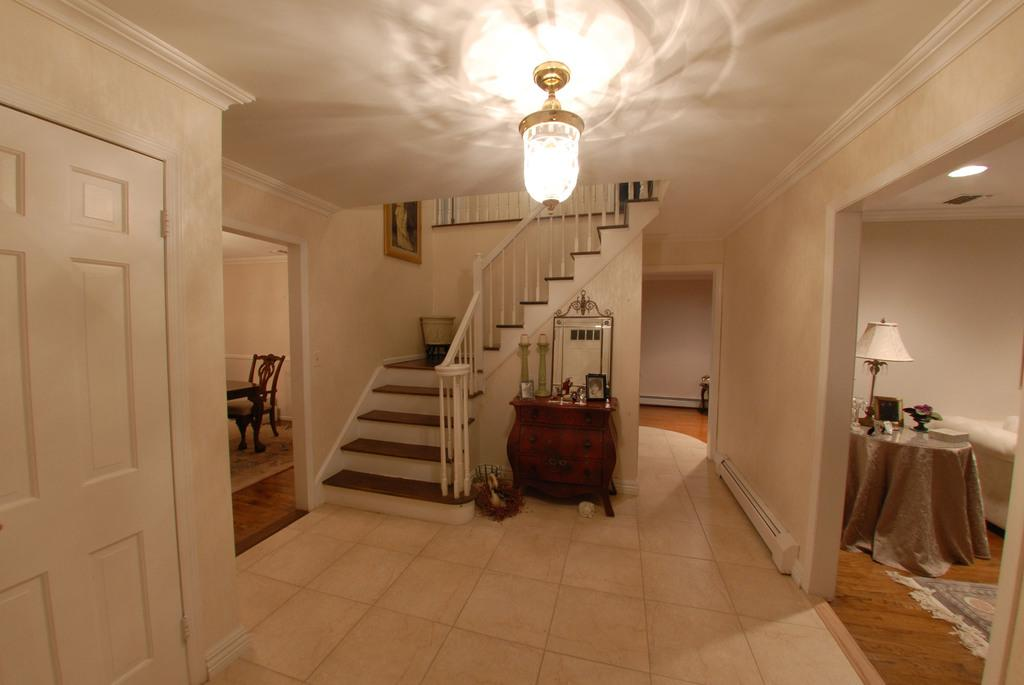What type of architectural feature is present in the image? There are steps in the image. Where is the table located in the image? The table is on the right side of the image. What is on the table in the image? There is a lamp on the table. What furniture is present on the left side of the image? There is a chair and a table on the left side of the image. What type of lighting is present in the middle of the room? There is a light in the middle of the room. What type of attack is being carried out by the sheep in the image? There are no sheep present in the image, so no attack can be observed. What type of writing instrument is being used by the quill in the image? There is no quill present in the image, so no writing instrument can be observed. 